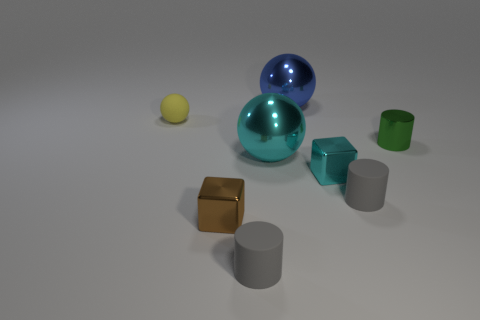How many objects in total can be counted in the image? There are a total of six objects in the image: two spheres, three cylinders, and one cube. 